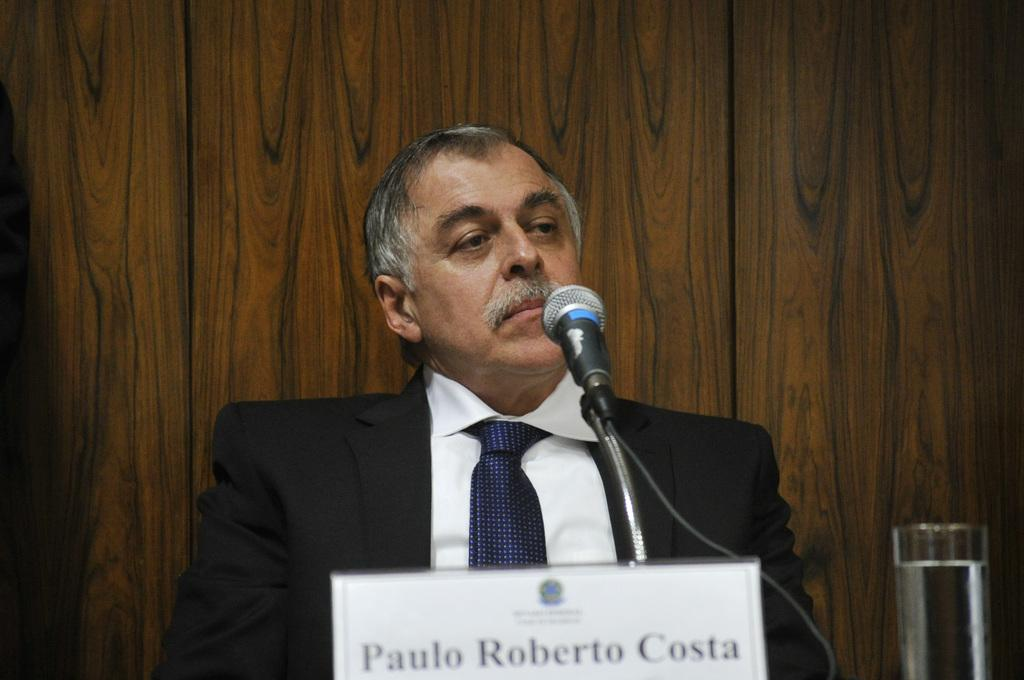Who is in the image? There is a man in the image. What is the man wearing? The man is wearing a formal suit. What can be seen on the table in the image? There is a name plate, a glass of water, and a mic with a stand on the table. What is the background of the image made of? There is a wall made of wood in the background. How many ants can be seen crawling on the man's suit in the image? There are no ants present in the image. What type of turkey is being served on the table in the image? There is no turkey present in the image; only a name plate, a glass of water, and a mic with a stand are on the table. 